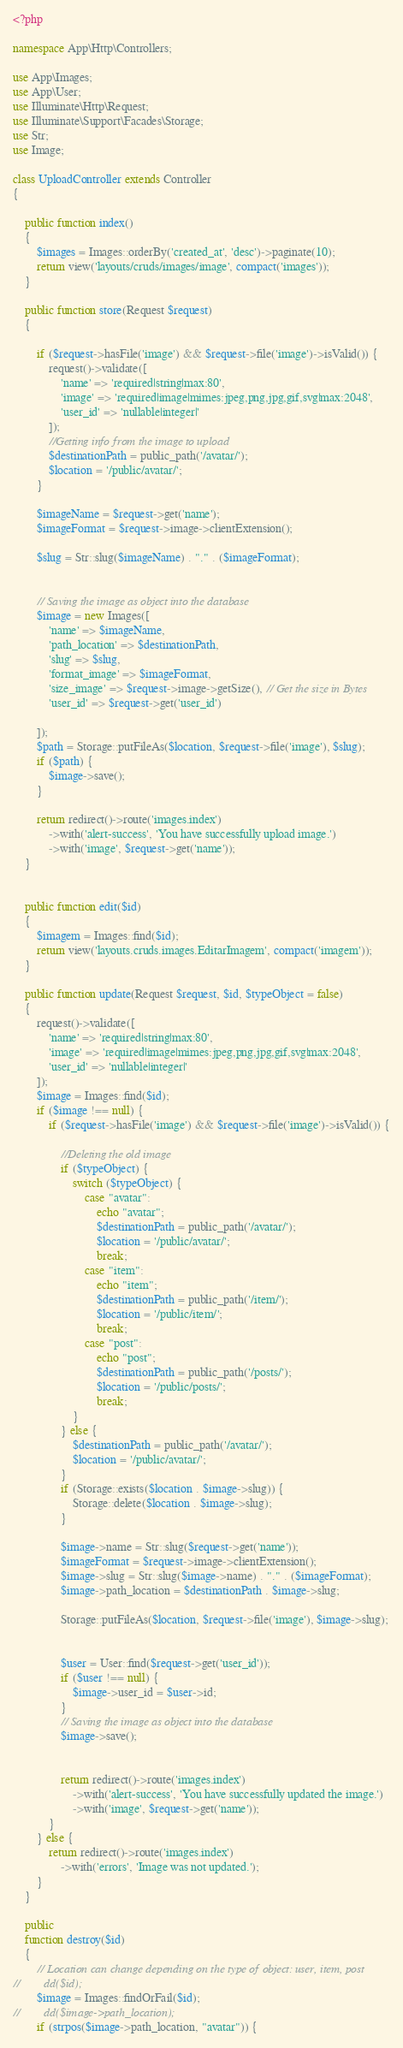Convert code to text. <code><loc_0><loc_0><loc_500><loc_500><_PHP_><?php

namespace App\Http\Controllers;

use App\Images;
use App\User;
use Illuminate\Http\Request;
use Illuminate\Support\Facades\Storage;
use Str;
use Image;

class UploadController extends Controller
{

    public function index()
    {
        $images = Images::orderBy('created_at', 'desc')->paginate(10);
        return view('layouts/cruds/images/image', compact('images'));
    }

    public function store(Request $request)
    {

        if ($request->hasFile('image') && $request->file('image')->isValid()) {
            request()->validate([
                'name' => 'required|string|max:80',
                'image' => 'required|image|mimes:jpeg,png,jpg,gif,svg|max:2048',
                'user_id' => 'nullable|integer|'
            ]);
            //Getting info from the image to upload
            $destinationPath = public_path('/avatar/');
            $location = '/public/avatar/';
        }

        $imageName = $request->get('name');
        $imageFormat = $request->image->clientExtension();

        $slug = Str::slug($imageName) . "." . ($imageFormat);


        // Saving the image as object into the database
        $image = new Images([
            'name' => $imageName,
            'path_location' => $destinationPath,
            'slug' => $slug,
            'format_image' => $imageFormat,
            'size_image' => $request->image->getSize(), // Get the size in Bytes
            'user_id' => $request->get('user_id')

        ]);
        $path = Storage::putFileAs($location, $request->file('image'), $slug);
        if ($path) {
            $image->save();
        }

        return redirect()->route('images.index')
            ->with('alert-success', 'You have successfully upload image.')
            ->with('image', $request->get('name'));
    }


    public function edit($id)
    {
        $imagem = Images::find($id);
        return view('layouts.cruds.images.EditarImagem', compact('imagem'));
    }

    public function update(Request $request, $id, $typeObject = false)
    {
        request()->validate([
            'name' => 'required|string|max:80',
            'image' => 'required|image|mimes:jpeg,png,jpg,gif,svg|max:2048',
            'user_id' => 'nullable|integer|'
        ]);
        $image = Images::find($id);
        if ($image !== null) {
            if ($request->hasFile('image') && $request->file('image')->isValid()) {

                //Deleting the old image
                if ($typeObject) {
                    switch ($typeObject) {
                        case "avatar":
                            echo "avatar";
                            $destinationPath = public_path('/avatar/');
                            $location = '/public/avatar/';
                            break;
                        case "item":
                            echo "item";
                            $destinationPath = public_path('/item/');
                            $location = '/public/item/';
                            break;
                        case "post":
                            echo "post";
                            $destinationPath = public_path('/posts/');
                            $location = '/public/posts/';
                            break;
                    }
                } else {
                    $destinationPath = public_path('/avatar/');
                    $location = '/public/avatar/';
                }
                if (Storage::exists($location . $image->slug)) {
                    Storage::delete($location . $image->slug);
                }

                $image->name = Str::slug($request->get('name'));
                $imageFormat = $request->image->clientExtension();
                $image->slug = Str::slug($image->name) . "." . ($imageFormat);
                $image->path_location = $destinationPath . $image->slug;

                Storage::putFileAs($location, $request->file('image'), $image->slug);


                $user = User::find($request->get('user_id'));
                if ($user !== null) {
                    $image->user_id = $user->id;
                }
                // Saving the image as object into the database
                $image->save();


                return redirect()->route('images.index')
                    ->with('alert-success', 'You have successfully updated the image.')
                    ->with('image', $request->get('name'));
            }
        } else {
            return redirect()->route('images.index')
                ->with('errors', 'Image was not updated.');
        }
    }

    public
    function destroy($id)
    {
        // Location can change depending on the type of object: user, item, post
//        dd($id);
        $image = Images::findOrFail($id);
//        dd($image->path_location);
        if (strpos($image->path_location, "avatar")) {</code> 